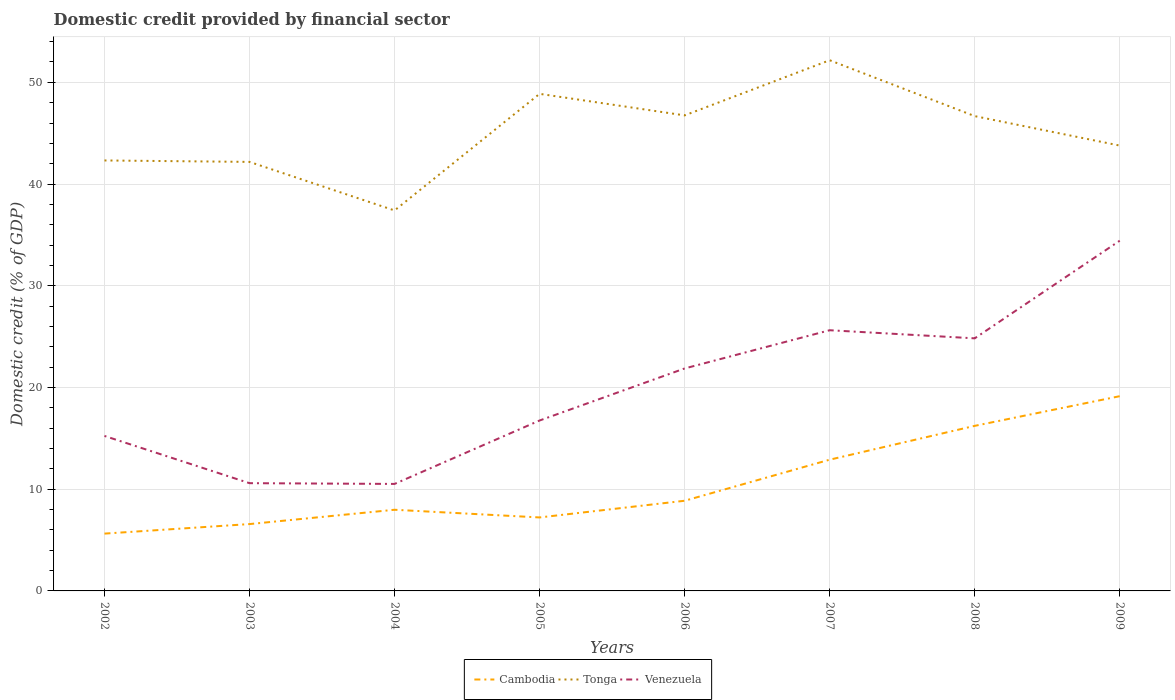Does the line corresponding to Venezuela intersect with the line corresponding to Tonga?
Make the answer very short. No. Is the number of lines equal to the number of legend labels?
Provide a short and direct response. Yes. Across all years, what is the maximum domestic credit in Tonga?
Your answer should be compact. 37.41. What is the total domestic credit in Venezuela in the graph?
Ensure brevity in your answer.  -3.76. What is the difference between the highest and the second highest domestic credit in Venezuela?
Make the answer very short. 23.91. How many lines are there?
Offer a very short reply. 3. How many years are there in the graph?
Ensure brevity in your answer.  8. What is the difference between two consecutive major ticks on the Y-axis?
Your answer should be compact. 10. Does the graph contain any zero values?
Provide a succinct answer. No. Does the graph contain grids?
Make the answer very short. Yes. Where does the legend appear in the graph?
Provide a succinct answer. Bottom center. How many legend labels are there?
Give a very brief answer. 3. How are the legend labels stacked?
Provide a succinct answer. Horizontal. What is the title of the graph?
Offer a terse response. Domestic credit provided by financial sector. Does "Netherlands" appear as one of the legend labels in the graph?
Your answer should be very brief. No. What is the label or title of the X-axis?
Ensure brevity in your answer.  Years. What is the label or title of the Y-axis?
Keep it short and to the point. Domestic credit (% of GDP). What is the Domestic credit (% of GDP) in Cambodia in 2002?
Make the answer very short. 5.63. What is the Domestic credit (% of GDP) of Tonga in 2002?
Provide a succinct answer. 42.32. What is the Domestic credit (% of GDP) of Venezuela in 2002?
Your answer should be very brief. 15.24. What is the Domestic credit (% of GDP) of Cambodia in 2003?
Your response must be concise. 6.57. What is the Domestic credit (% of GDP) in Tonga in 2003?
Offer a terse response. 42.18. What is the Domestic credit (% of GDP) in Venezuela in 2003?
Offer a very short reply. 10.59. What is the Domestic credit (% of GDP) of Cambodia in 2004?
Provide a short and direct response. 7.98. What is the Domestic credit (% of GDP) in Tonga in 2004?
Your response must be concise. 37.41. What is the Domestic credit (% of GDP) of Venezuela in 2004?
Provide a succinct answer. 10.52. What is the Domestic credit (% of GDP) of Cambodia in 2005?
Your answer should be compact. 7.22. What is the Domestic credit (% of GDP) in Tonga in 2005?
Your answer should be compact. 48.87. What is the Domestic credit (% of GDP) of Venezuela in 2005?
Your answer should be very brief. 16.75. What is the Domestic credit (% of GDP) in Cambodia in 2006?
Offer a very short reply. 8.86. What is the Domestic credit (% of GDP) of Tonga in 2006?
Make the answer very short. 46.75. What is the Domestic credit (% of GDP) of Venezuela in 2006?
Offer a terse response. 21.87. What is the Domestic credit (% of GDP) in Cambodia in 2007?
Your response must be concise. 12.9. What is the Domestic credit (% of GDP) of Tonga in 2007?
Give a very brief answer. 52.17. What is the Domestic credit (% of GDP) in Venezuela in 2007?
Your response must be concise. 25.63. What is the Domestic credit (% of GDP) of Cambodia in 2008?
Keep it short and to the point. 16.23. What is the Domestic credit (% of GDP) of Tonga in 2008?
Your answer should be compact. 46.68. What is the Domestic credit (% of GDP) of Venezuela in 2008?
Give a very brief answer. 24.83. What is the Domestic credit (% of GDP) of Cambodia in 2009?
Provide a succinct answer. 19.14. What is the Domestic credit (% of GDP) of Tonga in 2009?
Your response must be concise. 43.78. What is the Domestic credit (% of GDP) of Venezuela in 2009?
Offer a terse response. 34.43. Across all years, what is the maximum Domestic credit (% of GDP) of Cambodia?
Offer a terse response. 19.14. Across all years, what is the maximum Domestic credit (% of GDP) of Tonga?
Your answer should be very brief. 52.17. Across all years, what is the maximum Domestic credit (% of GDP) of Venezuela?
Offer a terse response. 34.43. Across all years, what is the minimum Domestic credit (% of GDP) in Cambodia?
Keep it short and to the point. 5.63. Across all years, what is the minimum Domestic credit (% of GDP) of Tonga?
Keep it short and to the point. 37.41. Across all years, what is the minimum Domestic credit (% of GDP) in Venezuela?
Ensure brevity in your answer.  10.52. What is the total Domestic credit (% of GDP) of Cambodia in the graph?
Your answer should be very brief. 84.55. What is the total Domestic credit (% of GDP) of Tonga in the graph?
Your answer should be compact. 360.16. What is the total Domestic credit (% of GDP) of Venezuela in the graph?
Provide a succinct answer. 159.86. What is the difference between the Domestic credit (% of GDP) of Cambodia in 2002 and that in 2003?
Make the answer very short. -0.94. What is the difference between the Domestic credit (% of GDP) of Tonga in 2002 and that in 2003?
Give a very brief answer. 0.14. What is the difference between the Domestic credit (% of GDP) in Venezuela in 2002 and that in 2003?
Your answer should be very brief. 4.64. What is the difference between the Domestic credit (% of GDP) of Cambodia in 2002 and that in 2004?
Provide a short and direct response. -2.34. What is the difference between the Domestic credit (% of GDP) in Tonga in 2002 and that in 2004?
Your answer should be compact. 4.91. What is the difference between the Domestic credit (% of GDP) in Venezuela in 2002 and that in 2004?
Offer a terse response. 4.72. What is the difference between the Domestic credit (% of GDP) of Cambodia in 2002 and that in 2005?
Provide a succinct answer. -1.59. What is the difference between the Domestic credit (% of GDP) in Tonga in 2002 and that in 2005?
Ensure brevity in your answer.  -6.55. What is the difference between the Domestic credit (% of GDP) of Venezuela in 2002 and that in 2005?
Provide a succinct answer. -1.52. What is the difference between the Domestic credit (% of GDP) of Cambodia in 2002 and that in 2006?
Keep it short and to the point. -3.23. What is the difference between the Domestic credit (% of GDP) in Tonga in 2002 and that in 2006?
Your response must be concise. -4.43. What is the difference between the Domestic credit (% of GDP) of Venezuela in 2002 and that in 2006?
Keep it short and to the point. -6.63. What is the difference between the Domestic credit (% of GDP) of Cambodia in 2002 and that in 2007?
Your answer should be very brief. -7.27. What is the difference between the Domestic credit (% of GDP) in Tonga in 2002 and that in 2007?
Provide a succinct answer. -9.85. What is the difference between the Domestic credit (% of GDP) in Venezuela in 2002 and that in 2007?
Provide a succinct answer. -10.39. What is the difference between the Domestic credit (% of GDP) of Cambodia in 2002 and that in 2008?
Your answer should be very brief. -10.59. What is the difference between the Domestic credit (% of GDP) in Tonga in 2002 and that in 2008?
Your answer should be compact. -4.36. What is the difference between the Domestic credit (% of GDP) in Venezuela in 2002 and that in 2008?
Offer a terse response. -9.59. What is the difference between the Domestic credit (% of GDP) of Cambodia in 2002 and that in 2009?
Provide a short and direct response. -13.51. What is the difference between the Domestic credit (% of GDP) of Tonga in 2002 and that in 2009?
Keep it short and to the point. -1.46. What is the difference between the Domestic credit (% of GDP) in Venezuela in 2002 and that in 2009?
Provide a short and direct response. -19.19. What is the difference between the Domestic credit (% of GDP) of Cambodia in 2003 and that in 2004?
Your answer should be very brief. -1.41. What is the difference between the Domestic credit (% of GDP) in Tonga in 2003 and that in 2004?
Give a very brief answer. 4.77. What is the difference between the Domestic credit (% of GDP) of Venezuela in 2003 and that in 2004?
Keep it short and to the point. 0.07. What is the difference between the Domestic credit (% of GDP) in Cambodia in 2003 and that in 2005?
Provide a short and direct response. -0.65. What is the difference between the Domestic credit (% of GDP) in Tonga in 2003 and that in 2005?
Make the answer very short. -6.69. What is the difference between the Domestic credit (% of GDP) of Venezuela in 2003 and that in 2005?
Offer a terse response. -6.16. What is the difference between the Domestic credit (% of GDP) of Cambodia in 2003 and that in 2006?
Provide a short and direct response. -2.29. What is the difference between the Domestic credit (% of GDP) in Tonga in 2003 and that in 2006?
Ensure brevity in your answer.  -4.57. What is the difference between the Domestic credit (% of GDP) in Venezuela in 2003 and that in 2006?
Your response must be concise. -11.28. What is the difference between the Domestic credit (% of GDP) in Cambodia in 2003 and that in 2007?
Provide a short and direct response. -6.33. What is the difference between the Domestic credit (% of GDP) in Tonga in 2003 and that in 2007?
Offer a very short reply. -9.99. What is the difference between the Domestic credit (% of GDP) of Venezuela in 2003 and that in 2007?
Give a very brief answer. -15.04. What is the difference between the Domestic credit (% of GDP) in Cambodia in 2003 and that in 2008?
Make the answer very short. -9.66. What is the difference between the Domestic credit (% of GDP) of Tonga in 2003 and that in 2008?
Make the answer very short. -4.5. What is the difference between the Domestic credit (% of GDP) in Venezuela in 2003 and that in 2008?
Give a very brief answer. -14.24. What is the difference between the Domestic credit (% of GDP) in Cambodia in 2003 and that in 2009?
Your answer should be very brief. -12.57. What is the difference between the Domestic credit (% of GDP) in Tonga in 2003 and that in 2009?
Keep it short and to the point. -1.6. What is the difference between the Domestic credit (% of GDP) in Venezuela in 2003 and that in 2009?
Provide a succinct answer. -23.84. What is the difference between the Domestic credit (% of GDP) of Cambodia in 2004 and that in 2005?
Provide a short and direct response. 0.76. What is the difference between the Domestic credit (% of GDP) in Tonga in 2004 and that in 2005?
Provide a succinct answer. -11.46. What is the difference between the Domestic credit (% of GDP) in Venezuela in 2004 and that in 2005?
Ensure brevity in your answer.  -6.24. What is the difference between the Domestic credit (% of GDP) in Cambodia in 2004 and that in 2006?
Offer a terse response. -0.88. What is the difference between the Domestic credit (% of GDP) of Tonga in 2004 and that in 2006?
Your answer should be compact. -9.35. What is the difference between the Domestic credit (% of GDP) in Venezuela in 2004 and that in 2006?
Offer a very short reply. -11.35. What is the difference between the Domestic credit (% of GDP) in Cambodia in 2004 and that in 2007?
Offer a terse response. -4.92. What is the difference between the Domestic credit (% of GDP) in Tonga in 2004 and that in 2007?
Make the answer very short. -14.77. What is the difference between the Domestic credit (% of GDP) in Venezuela in 2004 and that in 2007?
Ensure brevity in your answer.  -15.11. What is the difference between the Domestic credit (% of GDP) of Cambodia in 2004 and that in 2008?
Provide a succinct answer. -8.25. What is the difference between the Domestic credit (% of GDP) of Tonga in 2004 and that in 2008?
Provide a succinct answer. -9.27. What is the difference between the Domestic credit (% of GDP) in Venezuela in 2004 and that in 2008?
Your answer should be compact. -14.31. What is the difference between the Domestic credit (% of GDP) of Cambodia in 2004 and that in 2009?
Your answer should be very brief. -11.17. What is the difference between the Domestic credit (% of GDP) in Tonga in 2004 and that in 2009?
Keep it short and to the point. -6.38. What is the difference between the Domestic credit (% of GDP) in Venezuela in 2004 and that in 2009?
Make the answer very short. -23.91. What is the difference between the Domestic credit (% of GDP) of Cambodia in 2005 and that in 2006?
Your answer should be compact. -1.64. What is the difference between the Domestic credit (% of GDP) in Tonga in 2005 and that in 2006?
Give a very brief answer. 2.12. What is the difference between the Domestic credit (% of GDP) of Venezuela in 2005 and that in 2006?
Your answer should be compact. -5.12. What is the difference between the Domestic credit (% of GDP) in Cambodia in 2005 and that in 2007?
Keep it short and to the point. -5.68. What is the difference between the Domestic credit (% of GDP) in Tonga in 2005 and that in 2007?
Provide a succinct answer. -3.3. What is the difference between the Domestic credit (% of GDP) in Venezuela in 2005 and that in 2007?
Make the answer very short. -8.87. What is the difference between the Domestic credit (% of GDP) in Cambodia in 2005 and that in 2008?
Your answer should be compact. -9. What is the difference between the Domestic credit (% of GDP) of Tonga in 2005 and that in 2008?
Offer a terse response. 2.19. What is the difference between the Domestic credit (% of GDP) of Venezuela in 2005 and that in 2008?
Offer a terse response. -8.08. What is the difference between the Domestic credit (% of GDP) in Cambodia in 2005 and that in 2009?
Ensure brevity in your answer.  -11.92. What is the difference between the Domestic credit (% of GDP) of Tonga in 2005 and that in 2009?
Provide a succinct answer. 5.09. What is the difference between the Domestic credit (% of GDP) in Venezuela in 2005 and that in 2009?
Ensure brevity in your answer.  -17.68. What is the difference between the Domestic credit (% of GDP) in Cambodia in 2006 and that in 2007?
Give a very brief answer. -4.04. What is the difference between the Domestic credit (% of GDP) in Tonga in 2006 and that in 2007?
Your answer should be very brief. -5.42. What is the difference between the Domestic credit (% of GDP) in Venezuela in 2006 and that in 2007?
Provide a short and direct response. -3.76. What is the difference between the Domestic credit (% of GDP) in Cambodia in 2006 and that in 2008?
Your answer should be very brief. -7.36. What is the difference between the Domestic credit (% of GDP) of Tonga in 2006 and that in 2008?
Your response must be concise. 0.07. What is the difference between the Domestic credit (% of GDP) of Venezuela in 2006 and that in 2008?
Provide a succinct answer. -2.96. What is the difference between the Domestic credit (% of GDP) in Cambodia in 2006 and that in 2009?
Give a very brief answer. -10.28. What is the difference between the Domestic credit (% of GDP) of Tonga in 2006 and that in 2009?
Ensure brevity in your answer.  2.97. What is the difference between the Domestic credit (% of GDP) in Venezuela in 2006 and that in 2009?
Ensure brevity in your answer.  -12.56. What is the difference between the Domestic credit (% of GDP) in Cambodia in 2007 and that in 2008?
Your answer should be very brief. -3.33. What is the difference between the Domestic credit (% of GDP) of Tonga in 2007 and that in 2008?
Give a very brief answer. 5.49. What is the difference between the Domestic credit (% of GDP) of Venezuela in 2007 and that in 2008?
Keep it short and to the point. 0.8. What is the difference between the Domestic credit (% of GDP) of Cambodia in 2007 and that in 2009?
Ensure brevity in your answer.  -6.24. What is the difference between the Domestic credit (% of GDP) in Tonga in 2007 and that in 2009?
Your answer should be compact. 8.39. What is the difference between the Domestic credit (% of GDP) of Venezuela in 2007 and that in 2009?
Provide a short and direct response. -8.8. What is the difference between the Domestic credit (% of GDP) in Cambodia in 2008 and that in 2009?
Provide a short and direct response. -2.92. What is the difference between the Domestic credit (% of GDP) of Tonga in 2008 and that in 2009?
Offer a very short reply. 2.9. What is the difference between the Domestic credit (% of GDP) of Venezuela in 2008 and that in 2009?
Your answer should be very brief. -9.6. What is the difference between the Domestic credit (% of GDP) in Cambodia in 2002 and the Domestic credit (% of GDP) in Tonga in 2003?
Offer a very short reply. -36.54. What is the difference between the Domestic credit (% of GDP) in Cambodia in 2002 and the Domestic credit (% of GDP) in Venezuela in 2003?
Keep it short and to the point. -4.96. What is the difference between the Domestic credit (% of GDP) of Tonga in 2002 and the Domestic credit (% of GDP) of Venezuela in 2003?
Your answer should be compact. 31.73. What is the difference between the Domestic credit (% of GDP) of Cambodia in 2002 and the Domestic credit (% of GDP) of Tonga in 2004?
Provide a short and direct response. -31.77. What is the difference between the Domestic credit (% of GDP) of Cambodia in 2002 and the Domestic credit (% of GDP) of Venezuela in 2004?
Your answer should be very brief. -4.88. What is the difference between the Domestic credit (% of GDP) in Tonga in 2002 and the Domestic credit (% of GDP) in Venezuela in 2004?
Offer a terse response. 31.8. What is the difference between the Domestic credit (% of GDP) of Cambodia in 2002 and the Domestic credit (% of GDP) of Tonga in 2005?
Provide a succinct answer. -43.23. What is the difference between the Domestic credit (% of GDP) of Cambodia in 2002 and the Domestic credit (% of GDP) of Venezuela in 2005?
Your answer should be very brief. -11.12. What is the difference between the Domestic credit (% of GDP) of Tonga in 2002 and the Domestic credit (% of GDP) of Venezuela in 2005?
Your answer should be very brief. 25.57. What is the difference between the Domestic credit (% of GDP) in Cambodia in 2002 and the Domestic credit (% of GDP) in Tonga in 2006?
Ensure brevity in your answer.  -41.12. What is the difference between the Domestic credit (% of GDP) of Cambodia in 2002 and the Domestic credit (% of GDP) of Venezuela in 2006?
Your response must be concise. -16.24. What is the difference between the Domestic credit (% of GDP) in Tonga in 2002 and the Domestic credit (% of GDP) in Venezuela in 2006?
Offer a terse response. 20.45. What is the difference between the Domestic credit (% of GDP) in Cambodia in 2002 and the Domestic credit (% of GDP) in Tonga in 2007?
Your response must be concise. -46.54. What is the difference between the Domestic credit (% of GDP) in Cambodia in 2002 and the Domestic credit (% of GDP) in Venezuela in 2007?
Give a very brief answer. -19.99. What is the difference between the Domestic credit (% of GDP) of Tonga in 2002 and the Domestic credit (% of GDP) of Venezuela in 2007?
Your response must be concise. 16.69. What is the difference between the Domestic credit (% of GDP) of Cambodia in 2002 and the Domestic credit (% of GDP) of Tonga in 2008?
Offer a very short reply. -41.05. What is the difference between the Domestic credit (% of GDP) of Cambodia in 2002 and the Domestic credit (% of GDP) of Venezuela in 2008?
Make the answer very short. -19.2. What is the difference between the Domestic credit (% of GDP) in Tonga in 2002 and the Domestic credit (% of GDP) in Venezuela in 2008?
Give a very brief answer. 17.49. What is the difference between the Domestic credit (% of GDP) in Cambodia in 2002 and the Domestic credit (% of GDP) in Tonga in 2009?
Ensure brevity in your answer.  -38.15. What is the difference between the Domestic credit (% of GDP) in Cambodia in 2002 and the Domestic credit (% of GDP) in Venezuela in 2009?
Your response must be concise. -28.8. What is the difference between the Domestic credit (% of GDP) in Tonga in 2002 and the Domestic credit (% of GDP) in Venezuela in 2009?
Keep it short and to the point. 7.89. What is the difference between the Domestic credit (% of GDP) in Cambodia in 2003 and the Domestic credit (% of GDP) in Tonga in 2004?
Offer a very short reply. -30.83. What is the difference between the Domestic credit (% of GDP) in Cambodia in 2003 and the Domestic credit (% of GDP) in Venezuela in 2004?
Offer a terse response. -3.95. What is the difference between the Domestic credit (% of GDP) of Tonga in 2003 and the Domestic credit (% of GDP) of Venezuela in 2004?
Provide a short and direct response. 31.66. What is the difference between the Domestic credit (% of GDP) in Cambodia in 2003 and the Domestic credit (% of GDP) in Tonga in 2005?
Ensure brevity in your answer.  -42.3. What is the difference between the Domestic credit (% of GDP) of Cambodia in 2003 and the Domestic credit (% of GDP) of Venezuela in 2005?
Ensure brevity in your answer.  -10.18. What is the difference between the Domestic credit (% of GDP) of Tonga in 2003 and the Domestic credit (% of GDP) of Venezuela in 2005?
Your answer should be very brief. 25.42. What is the difference between the Domestic credit (% of GDP) of Cambodia in 2003 and the Domestic credit (% of GDP) of Tonga in 2006?
Give a very brief answer. -40.18. What is the difference between the Domestic credit (% of GDP) of Cambodia in 2003 and the Domestic credit (% of GDP) of Venezuela in 2006?
Keep it short and to the point. -15.3. What is the difference between the Domestic credit (% of GDP) in Tonga in 2003 and the Domestic credit (% of GDP) in Venezuela in 2006?
Provide a succinct answer. 20.31. What is the difference between the Domestic credit (% of GDP) of Cambodia in 2003 and the Domestic credit (% of GDP) of Tonga in 2007?
Your answer should be compact. -45.6. What is the difference between the Domestic credit (% of GDP) of Cambodia in 2003 and the Domestic credit (% of GDP) of Venezuela in 2007?
Ensure brevity in your answer.  -19.06. What is the difference between the Domestic credit (% of GDP) of Tonga in 2003 and the Domestic credit (% of GDP) of Venezuela in 2007?
Make the answer very short. 16.55. What is the difference between the Domestic credit (% of GDP) in Cambodia in 2003 and the Domestic credit (% of GDP) in Tonga in 2008?
Offer a terse response. -40.11. What is the difference between the Domestic credit (% of GDP) of Cambodia in 2003 and the Domestic credit (% of GDP) of Venezuela in 2008?
Your answer should be compact. -18.26. What is the difference between the Domestic credit (% of GDP) in Tonga in 2003 and the Domestic credit (% of GDP) in Venezuela in 2008?
Make the answer very short. 17.35. What is the difference between the Domestic credit (% of GDP) of Cambodia in 2003 and the Domestic credit (% of GDP) of Tonga in 2009?
Make the answer very short. -37.21. What is the difference between the Domestic credit (% of GDP) of Cambodia in 2003 and the Domestic credit (% of GDP) of Venezuela in 2009?
Provide a succinct answer. -27.86. What is the difference between the Domestic credit (% of GDP) of Tonga in 2003 and the Domestic credit (% of GDP) of Venezuela in 2009?
Give a very brief answer. 7.75. What is the difference between the Domestic credit (% of GDP) in Cambodia in 2004 and the Domestic credit (% of GDP) in Tonga in 2005?
Offer a very short reply. -40.89. What is the difference between the Domestic credit (% of GDP) in Cambodia in 2004 and the Domestic credit (% of GDP) in Venezuela in 2005?
Give a very brief answer. -8.78. What is the difference between the Domestic credit (% of GDP) in Tonga in 2004 and the Domestic credit (% of GDP) in Venezuela in 2005?
Provide a short and direct response. 20.65. What is the difference between the Domestic credit (% of GDP) in Cambodia in 2004 and the Domestic credit (% of GDP) in Tonga in 2006?
Your response must be concise. -38.77. What is the difference between the Domestic credit (% of GDP) in Cambodia in 2004 and the Domestic credit (% of GDP) in Venezuela in 2006?
Give a very brief answer. -13.89. What is the difference between the Domestic credit (% of GDP) in Tonga in 2004 and the Domestic credit (% of GDP) in Venezuela in 2006?
Ensure brevity in your answer.  15.54. What is the difference between the Domestic credit (% of GDP) of Cambodia in 2004 and the Domestic credit (% of GDP) of Tonga in 2007?
Make the answer very short. -44.19. What is the difference between the Domestic credit (% of GDP) in Cambodia in 2004 and the Domestic credit (% of GDP) in Venezuela in 2007?
Your response must be concise. -17.65. What is the difference between the Domestic credit (% of GDP) of Tonga in 2004 and the Domestic credit (% of GDP) of Venezuela in 2007?
Your answer should be very brief. 11.78. What is the difference between the Domestic credit (% of GDP) in Cambodia in 2004 and the Domestic credit (% of GDP) in Tonga in 2008?
Provide a short and direct response. -38.7. What is the difference between the Domestic credit (% of GDP) of Cambodia in 2004 and the Domestic credit (% of GDP) of Venezuela in 2008?
Your answer should be compact. -16.85. What is the difference between the Domestic credit (% of GDP) in Tonga in 2004 and the Domestic credit (% of GDP) in Venezuela in 2008?
Your answer should be very brief. 12.57. What is the difference between the Domestic credit (% of GDP) of Cambodia in 2004 and the Domestic credit (% of GDP) of Tonga in 2009?
Make the answer very short. -35.8. What is the difference between the Domestic credit (% of GDP) of Cambodia in 2004 and the Domestic credit (% of GDP) of Venezuela in 2009?
Provide a short and direct response. -26.45. What is the difference between the Domestic credit (% of GDP) of Tonga in 2004 and the Domestic credit (% of GDP) of Venezuela in 2009?
Offer a terse response. 2.98. What is the difference between the Domestic credit (% of GDP) of Cambodia in 2005 and the Domestic credit (% of GDP) of Tonga in 2006?
Your answer should be compact. -39.53. What is the difference between the Domestic credit (% of GDP) in Cambodia in 2005 and the Domestic credit (% of GDP) in Venezuela in 2006?
Your answer should be very brief. -14.65. What is the difference between the Domestic credit (% of GDP) in Tonga in 2005 and the Domestic credit (% of GDP) in Venezuela in 2006?
Your response must be concise. 27. What is the difference between the Domestic credit (% of GDP) in Cambodia in 2005 and the Domestic credit (% of GDP) in Tonga in 2007?
Make the answer very short. -44.95. What is the difference between the Domestic credit (% of GDP) in Cambodia in 2005 and the Domestic credit (% of GDP) in Venezuela in 2007?
Your answer should be compact. -18.41. What is the difference between the Domestic credit (% of GDP) in Tonga in 2005 and the Domestic credit (% of GDP) in Venezuela in 2007?
Ensure brevity in your answer.  23.24. What is the difference between the Domestic credit (% of GDP) in Cambodia in 2005 and the Domestic credit (% of GDP) in Tonga in 2008?
Make the answer very short. -39.46. What is the difference between the Domestic credit (% of GDP) of Cambodia in 2005 and the Domestic credit (% of GDP) of Venezuela in 2008?
Give a very brief answer. -17.61. What is the difference between the Domestic credit (% of GDP) of Tonga in 2005 and the Domestic credit (% of GDP) of Venezuela in 2008?
Your answer should be very brief. 24.04. What is the difference between the Domestic credit (% of GDP) of Cambodia in 2005 and the Domestic credit (% of GDP) of Tonga in 2009?
Your response must be concise. -36.56. What is the difference between the Domestic credit (% of GDP) in Cambodia in 2005 and the Domestic credit (% of GDP) in Venezuela in 2009?
Make the answer very short. -27.21. What is the difference between the Domestic credit (% of GDP) in Tonga in 2005 and the Domestic credit (% of GDP) in Venezuela in 2009?
Your answer should be compact. 14.44. What is the difference between the Domestic credit (% of GDP) in Cambodia in 2006 and the Domestic credit (% of GDP) in Tonga in 2007?
Your response must be concise. -43.31. What is the difference between the Domestic credit (% of GDP) of Cambodia in 2006 and the Domestic credit (% of GDP) of Venezuela in 2007?
Your response must be concise. -16.76. What is the difference between the Domestic credit (% of GDP) of Tonga in 2006 and the Domestic credit (% of GDP) of Venezuela in 2007?
Make the answer very short. 21.12. What is the difference between the Domestic credit (% of GDP) in Cambodia in 2006 and the Domestic credit (% of GDP) in Tonga in 2008?
Offer a very short reply. -37.82. What is the difference between the Domestic credit (% of GDP) of Cambodia in 2006 and the Domestic credit (% of GDP) of Venezuela in 2008?
Your answer should be very brief. -15.97. What is the difference between the Domestic credit (% of GDP) of Tonga in 2006 and the Domestic credit (% of GDP) of Venezuela in 2008?
Your response must be concise. 21.92. What is the difference between the Domestic credit (% of GDP) in Cambodia in 2006 and the Domestic credit (% of GDP) in Tonga in 2009?
Give a very brief answer. -34.92. What is the difference between the Domestic credit (% of GDP) of Cambodia in 2006 and the Domestic credit (% of GDP) of Venezuela in 2009?
Keep it short and to the point. -25.57. What is the difference between the Domestic credit (% of GDP) of Tonga in 2006 and the Domestic credit (% of GDP) of Venezuela in 2009?
Provide a succinct answer. 12.32. What is the difference between the Domestic credit (% of GDP) in Cambodia in 2007 and the Domestic credit (% of GDP) in Tonga in 2008?
Offer a terse response. -33.78. What is the difference between the Domestic credit (% of GDP) of Cambodia in 2007 and the Domestic credit (% of GDP) of Venezuela in 2008?
Your answer should be compact. -11.93. What is the difference between the Domestic credit (% of GDP) of Tonga in 2007 and the Domestic credit (% of GDP) of Venezuela in 2008?
Your response must be concise. 27.34. What is the difference between the Domestic credit (% of GDP) in Cambodia in 2007 and the Domestic credit (% of GDP) in Tonga in 2009?
Provide a succinct answer. -30.88. What is the difference between the Domestic credit (% of GDP) of Cambodia in 2007 and the Domestic credit (% of GDP) of Venezuela in 2009?
Provide a succinct answer. -21.53. What is the difference between the Domestic credit (% of GDP) in Tonga in 2007 and the Domestic credit (% of GDP) in Venezuela in 2009?
Your response must be concise. 17.74. What is the difference between the Domestic credit (% of GDP) of Cambodia in 2008 and the Domestic credit (% of GDP) of Tonga in 2009?
Give a very brief answer. -27.56. What is the difference between the Domestic credit (% of GDP) in Cambodia in 2008 and the Domestic credit (% of GDP) in Venezuela in 2009?
Offer a terse response. -18.2. What is the difference between the Domestic credit (% of GDP) of Tonga in 2008 and the Domestic credit (% of GDP) of Venezuela in 2009?
Give a very brief answer. 12.25. What is the average Domestic credit (% of GDP) in Cambodia per year?
Your response must be concise. 10.57. What is the average Domestic credit (% of GDP) in Tonga per year?
Offer a very short reply. 45.02. What is the average Domestic credit (% of GDP) in Venezuela per year?
Offer a very short reply. 19.98. In the year 2002, what is the difference between the Domestic credit (% of GDP) of Cambodia and Domestic credit (% of GDP) of Tonga?
Keep it short and to the point. -36.69. In the year 2002, what is the difference between the Domestic credit (% of GDP) of Cambodia and Domestic credit (% of GDP) of Venezuela?
Offer a terse response. -9.6. In the year 2002, what is the difference between the Domestic credit (% of GDP) of Tonga and Domestic credit (% of GDP) of Venezuela?
Offer a terse response. 27.08. In the year 2003, what is the difference between the Domestic credit (% of GDP) in Cambodia and Domestic credit (% of GDP) in Tonga?
Provide a succinct answer. -35.61. In the year 2003, what is the difference between the Domestic credit (% of GDP) of Cambodia and Domestic credit (% of GDP) of Venezuela?
Offer a terse response. -4.02. In the year 2003, what is the difference between the Domestic credit (% of GDP) of Tonga and Domestic credit (% of GDP) of Venezuela?
Offer a very short reply. 31.59. In the year 2004, what is the difference between the Domestic credit (% of GDP) of Cambodia and Domestic credit (% of GDP) of Tonga?
Your answer should be very brief. -29.43. In the year 2004, what is the difference between the Domestic credit (% of GDP) of Cambodia and Domestic credit (% of GDP) of Venezuela?
Provide a succinct answer. -2.54. In the year 2004, what is the difference between the Domestic credit (% of GDP) in Tonga and Domestic credit (% of GDP) in Venezuela?
Ensure brevity in your answer.  26.89. In the year 2005, what is the difference between the Domestic credit (% of GDP) in Cambodia and Domestic credit (% of GDP) in Tonga?
Provide a succinct answer. -41.65. In the year 2005, what is the difference between the Domestic credit (% of GDP) of Cambodia and Domestic credit (% of GDP) of Venezuela?
Keep it short and to the point. -9.53. In the year 2005, what is the difference between the Domestic credit (% of GDP) of Tonga and Domestic credit (% of GDP) of Venezuela?
Your answer should be very brief. 32.12. In the year 2006, what is the difference between the Domestic credit (% of GDP) in Cambodia and Domestic credit (% of GDP) in Tonga?
Ensure brevity in your answer.  -37.89. In the year 2006, what is the difference between the Domestic credit (% of GDP) of Cambodia and Domestic credit (% of GDP) of Venezuela?
Offer a very short reply. -13.01. In the year 2006, what is the difference between the Domestic credit (% of GDP) in Tonga and Domestic credit (% of GDP) in Venezuela?
Offer a terse response. 24.88. In the year 2007, what is the difference between the Domestic credit (% of GDP) in Cambodia and Domestic credit (% of GDP) in Tonga?
Keep it short and to the point. -39.27. In the year 2007, what is the difference between the Domestic credit (% of GDP) of Cambodia and Domestic credit (% of GDP) of Venezuela?
Provide a short and direct response. -12.73. In the year 2007, what is the difference between the Domestic credit (% of GDP) of Tonga and Domestic credit (% of GDP) of Venezuela?
Your answer should be very brief. 26.54. In the year 2008, what is the difference between the Domestic credit (% of GDP) in Cambodia and Domestic credit (% of GDP) in Tonga?
Keep it short and to the point. -30.45. In the year 2008, what is the difference between the Domestic credit (% of GDP) of Cambodia and Domestic credit (% of GDP) of Venezuela?
Your response must be concise. -8.6. In the year 2008, what is the difference between the Domestic credit (% of GDP) of Tonga and Domestic credit (% of GDP) of Venezuela?
Give a very brief answer. 21.85. In the year 2009, what is the difference between the Domestic credit (% of GDP) of Cambodia and Domestic credit (% of GDP) of Tonga?
Make the answer very short. -24.64. In the year 2009, what is the difference between the Domestic credit (% of GDP) of Cambodia and Domestic credit (% of GDP) of Venezuela?
Offer a very short reply. -15.29. In the year 2009, what is the difference between the Domestic credit (% of GDP) of Tonga and Domestic credit (% of GDP) of Venezuela?
Keep it short and to the point. 9.35. What is the ratio of the Domestic credit (% of GDP) in Cambodia in 2002 to that in 2003?
Your answer should be compact. 0.86. What is the ratio of the Domestic credit (% of GDP) of Tonga in 2002 to that in 2003?
Offer a terse response. 1. What is the ratio of the Domestic credit (% of GDP) in Venezuela in 2002 to that in 2003?
Provide a short and direct response. 1.44. What is the ratio of the Domestic credit (% of GDP) of Cambodia in 2002 to that in 2004?
Your answer should be compact. 0.71. What is the ratio of the Domestic credit (% of GDP) in Tonga in 2002 to that in 2004?
Give a very brief answer. 1.13. What is the ratio of the Domestic credit (% of GDP) of Venezuela in 2002 to that in 2004?
Ensure brevity in your answer.  1.45. What is the ratio of the Domestic credit (% of GDP) of Cambodia in 2002 to that in 2005?
Offer a very short reply. 0.78. What is the ratio of the Domestic credit (% of GDP) of Tonga in 2002 to that in 2005?
Provide a short and direct response. 0.87. What is the ratio of the Domestic credit (% of GDP) in Venezuela in 2002 to that in 2005?
Provide a succinct answer. 0.91. What is the ratio of the Domestic credit (% of GDP) in Cambodia in 2002 to that in 2006?
Your answer should be very brief. 0.64. What is the ratio of the Domestic credit (% of GDP) of Tonga in 2002 to that in 2006?
Your response must be concise. 0.91. What is the ratio of the Domestic credit (% of GDP) in Venezuela in 2002 to that in 2006?
Your answer should be very brief. 0.7. What is the ratio of the Domestic credit (% of GDP) in Cambodia in 2002 to that in 2007?
Offer a terse response. 0.44. What is the ratio of the Domestic credit (% of GDP) in Tonga in 2002 to that in 2007?
Your response must be concise. 0.81. What is the ratio of the Domestic credit (% of GDP) of Venezuela in 2002 to that in 2007?
Make the answer very short. 0.59. What is the ratio of the Domestic credit (% of GDP) of Cambodia in 2002 to that in 2008?
Offer a very short reply. 0.35. What is the ratio of the Domestic credit (% of GDP) in Tonga in 2002 to that in 2008?
Keep it short and to the point. 0.91. What is the ratio of the Domestic credit (% of GDP) in Venezuela in 2002 to that in 2008?
Give a very brief answer. 0.61. What is the ratio of the Domestic credit (% of GDP) in Cambodia in 2002 to that in 2009?
Keep it short and to the point. 0.29. What is the ratio of the Domestic credit (% of GDP) of Tonga in 2002 to that in 2009?
Give a very brief answer. 0.97. What is the ratio of the Domestic credit (% of GDP) of Venezuela in 2002 to that in 2009?
Your answer should be very brief. 0.44. What is the ratio of the Domestic credit (% of GDP) of Cambodia in 2003 to that in 2004?
Keep it short and to the point. 0.82. What is the ratio of the Domestic credit (% of GDP) of Tonga in 2003 to that in 2004?
Your response must be concise. 1.13. What is the ratio of the Domestic credit (% of GDP) of Venezuela in 2003 to that in 2004?
Offer a very short reply. 1.01. What is the ratio of the Domestic credit (% of GDP) in Cambodia in 2003 to that in 2005?
Provide a short and direct response. 0.91. What is the ratio of the Domestic credit (% of GDP) of Tonga in 2003 to that in 2005?
Your response must be concise. 0.86. What is the ratio of the Domestic credit (% of GDP) of Venezuela in 2003 to that in 2005?
Offer a terse response. 0.63. What is the ratio of the Domestic credit (% of GDP) in Cambodia in 2003 to that in 2006?
Offer a terse response. 0.74. What is the ratio of the Domestic credit (% of GDP) in Tonga in 2003 to that in 2006?
Provide a short and direct response. 0.9. What is the ratio of the Domestic credit (% of GDP) of Venezuela in 2003 to that in 2006?
Offer a very short reply. 0.48. What is the ratio of the Domestic credit (% of GDP) of Cambodia in 2003 to that in 2007?
Your response must be concise. 0.51. What is the ratio of the Domestic credit (% of GDP) in Tonga in 2003 to that in 2007?
Your answer should be compact. 0.81. What is the ratio of the Domestic credit (% of GDP) of Venezuela in 2003 to that in 2007?
Provide a short and direct response. 0.41. What is the ratio of the Domestic credit (% of GDP) in Cambodia in 2003 to that in 2008?
Provide a short and direct response. 0.41. What is the ratio of the Domestic credit (% of GDP) of Tonga in 2003 to that in 2008?
Provide a succinct answer. 0.9. What is the ratio of the Domestic credit (% of GDP) in Venezuela in 2003 to that in 2008?
Offer a terse response. 0.43. What is the ratio of the Domestic credit (% of GDP) in Cambodia in 2003 to that in 2009?
Ensure brevity in your answer.  0.34. What is the ratio of the Domestic credit (% of GDP) of Tonga in 2003 to that in 2009?
Your answer should be compact. 0.96. What is the ratio of the Domestic credit (% of GDP) of Venezuela in 2003 to that in 2009?
Provide a short and direct response. 0.31. What is the ratio of the Domestic credit (% of GDP) of Cambodia in 2004 to that in 2005?
Provide a succinct answer. 1.1. What is the ratio of the Domestic credit (% of GDP) of Tonga in 2004 to that in 2005?
Give a very brief answer. 0.77. What is the ratio of the Domestic credit (% of GDP) in Venezuela in 2004 to that in 2005?
Offer a terse response. 0.63. What is the ratio of the Domestic credit (% of GDP) in Cambodia in 2004 to that in 2006?
Make the answer very short. 0.9. What is the ratio of the Domestic credit (% of GDP) of Tonga in 2004 to that in 2006?
Make the answer very short. 0.8. What is the ratio of the Domestic credit (% of GDP) of Venezuela in 2004 to that in 2006?
Ensure brevity in your answer.  0.48. What is the ratio of the Domestic credit (% of GDP) in Cambodia in 2004 to that in 2007?
Make the answer very short. 0.62. What is the ratio of the Domestic credit (% of GDP) in Tonga in 2004 to that in 2007?
Make the answer very short. 0.72. What is the ratio of the Domestic credit (% of GDP) of Venezuela in 2004 to that in 2007?
Provide a succinct answer. 0.41. What is the ratio of the Domestic credit (% of GDP) of Cambodia in 2004 to that in 2008?
Provide a short and direct response. 0.49. What is the ratio of the Domestic credit (% of GDP) of Tonga in 2004 to that in 2008?
Provide a short and direct response. 0.8. What is the ratio of the Domestic credit (% of GDP) of Venezuela in 2004 to that in 2008?
Your response must be concise. 0.42. What is the ratio of the Domestic credit (% of GDP) of Cambodia in 2004 to that in 2009?
Provide a succinct answer. 0.42. What is the ratio of the Domestic credit (% of GDP) in Tonga in 2004 to that in 2009?
Ensure brevity in your answer.  0.85. What is the ratio of the Domestic credit (% of GDP) of Venezuela in 2004 to that in 2009?
Your answer should be very brief. 0.31. What is the ratio of the Domestic credit (% of GDP) of Cambodia in 2005 to that in 2006?
Your response must be concise. 0.81. What is the ratio of the Domestic credit (% of GDP) in Tonga in 2005 to that in 2006?
Provide a short and direct response. 1.05. What is the ratio of the Domestic credit (% of GDP) of Venezuela in 2005 to that in 2006?
Your answer should be very brief. 0.77. What is the ratio of the Domestic credit (% of GDP) in Cambodia in 2005 to that in 2007?
Make the answer very short. 0.56. What is the ratio of the Domestic credit (% of GDP) of Tonga in 2005 to that in 2007?
Keep it short and to the point. 0.94. What is the ratio of the Domestic credit (% of GDP) in Venezuela in 2005 to that in 2007?
Give a very brief answer. 0.65. What is the ratio of the Domestic credit (% of GDP) of Cambodia in 2005 to that in 2008?
Give a very brief answer. 0.45. What is the ratio of the Domestic credit (% of GDP) in Tonga in 2005 to that in 2008?
Offer a terse response. 1.05. What is the ratio of the Domestic credit (% of GDP) of Venezuela in 2005 to that in 2008?
Your response must be concise. 0.67. What is the ratio of the Domestic credit (% of GDP) of Cambodia in 2005 to that in 2009?
Your answer should be very brief. 0.38. What is the ratio of the Domestic credit (% of GDP) of Tonga in 2005 to that in 2009?
Offer a terse response. 1.12. What is the ratio of the Domestic credit (% of GDP) in Venezuela in 2005 to that in 2009?
Make the answer very short. 0.49. What is the ratio of the Domestic credit (% of GDP) of Cambodia in 2006 to that in 2007?
Make the answer very short. 0.69. What is the ratio of the Domestic credit (% of GDP) of Tonga in 2006 to that in 2007?
Your response must be concise. 0.9. What is the ratio of the Domestic credit (% of GDP) of Venezuela in 2006 to that in 2007?
Offer a terse response. 0.85. What is the ratio of the Domestic credit (% of GDP) of Cambodia in 2006 to that in 2008?
Ensure brevity in your answer.  0.55. What is the ratio of the Domestic credit (% of GDP) in Tonga in 2006 to that in 2008?
Make the answer very short. 1. What is the ratio of the Domestic credit (% of GDP) in Venezuela in 2006 to that in 2008?
Your answer should be very brief. 0.88. What is the ratio of the Domestic credit (% of GDP) in Cambodia in 2006 to that in 2009?
Your answer should be very brief. 0.46. What is the ratio of the Domestic credit (% of GDP) in Tonga in 2006 to that in 2009?
Give a very brief answer. 1.07. What is the ratio of the Domestic credit (% of GDP) of Venezuela in 2006 to that in 2009?
Your answer should be compact. 0.64. What is the ratio of the Domestic credit (% of GDP) in Cambodia in 2007 to that in 2008?
Provide a succinct answer. 0.8. What is the ratio of the Domestic credit (% of GDP) of Tonga in 2007 to that in 2008?
Offer a terse response. 1.12. What is the ratio of the Domestic credit (% of GDP) in Venezuela in 2007 to that in 2008?
Give a very brief answer. 1.03. What is the ratio of the Domestic credit (% of GDP) of Cambodia in 2007 to that in 2009?
Offer a very short reply. 0.67. What is the ratio of the Domestic credit (% of GDP) of Tonga in 2007 to that in 2009?
Provide a succinct answer. 1.19. What is the ratio of the Domestic credit (% of GDP) of Venezuela in 2007 to that in 2009?
Your answer should be very brief. 0.74. What is the ratio of the Domestic credit (% of GDP) in Cambodia in 2008 to that in 2009?
Offer a terse response. 0.85. What is the ratio of the Domestic credit (% of GDP) of Tonga in 2008 to that in 2009?
Ensure brevity in your answer.  1.07. What is the ratio of the Domestic credit (% of GDP) of Venezuela in 2008 to that in 2009?
Provide a succinct answer. 0.72. What is the difference between the highest and the second highest Domestic credit (% of GDP) of Cambodia?
Make the answer very short. 2.92. What is the difference between the highest and the second highest Domestic credit (% of GDP) of Tonga?
Your answer should be compact. 3.3. What is the difference between the highest and the second highest Domestic credit (% of GDP) in Venezuela?
Make the answer very short. 8.8. What is the difference between the highest and the lowest Domestic credit (% of GDP) of Cambodia?
Offer a very short reply. 13.51. What is the difference between the highest and the lowest Domestic credit (% of GDP) of Tonga?
Give a very brief answer. 14.77. What is the difference between the highest and the lowest Domestic credit (% of GDP) in Venezuela?
Offer a very short reply. 23.91. 